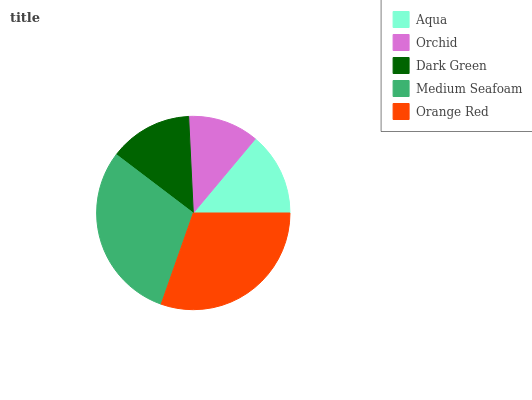Is Orchid the minimum?
Answer yes or no. Yes. Is Orange Red the maximum?
Answer yes or no. Yes. Is Dark Green the minimum?
Answer yes or no. No. Is Dark Green the maximum?
Answer yes or no. No. Is Dark Green greater than Orchid?
Answer yes or no. Yes. Is Orchid less than Dark Green?
Answer yes or no. Yes. Is Orchid greater than Dark Green?
Answer yes or no. No. Is Dark Green less than Orchid?
Answer yes or no. No. Is Aqua the high median?
Answer yes or no. Yes. Is Aqua the low median?
Answer yes or no. Yes. Is Orange Red the high median?
Answer yes or no. No. Is Dark Green the low median?
Answer yes or no. No. 